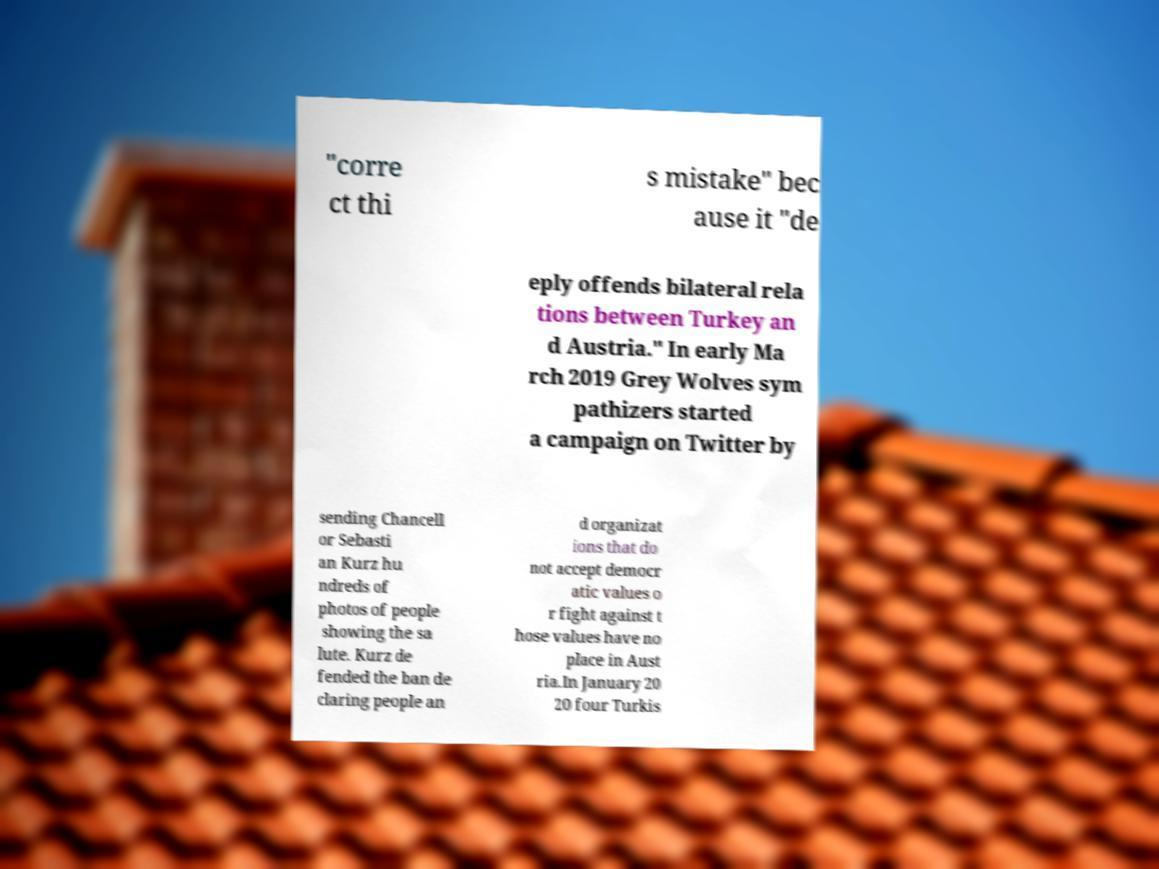What messages or text are displayed in this image? I need them in a readable, typed format. "corre ct thi s mistake" bec ause it "de eply offends bilateral rela tions between Turkey an d Austria." In early Ma rch 2019 Grey Wolves sym pathizers started a campaign on Twitter by sending Chancell or Sebasti an Kurz hu ndreds of photos of people showing the sa lute. Kurz de fended the ban de claring people an d organizat ions that do not accept democr atic values o r fight against t hose values have no place in Aust ria.In January 20 20 four Turkis 